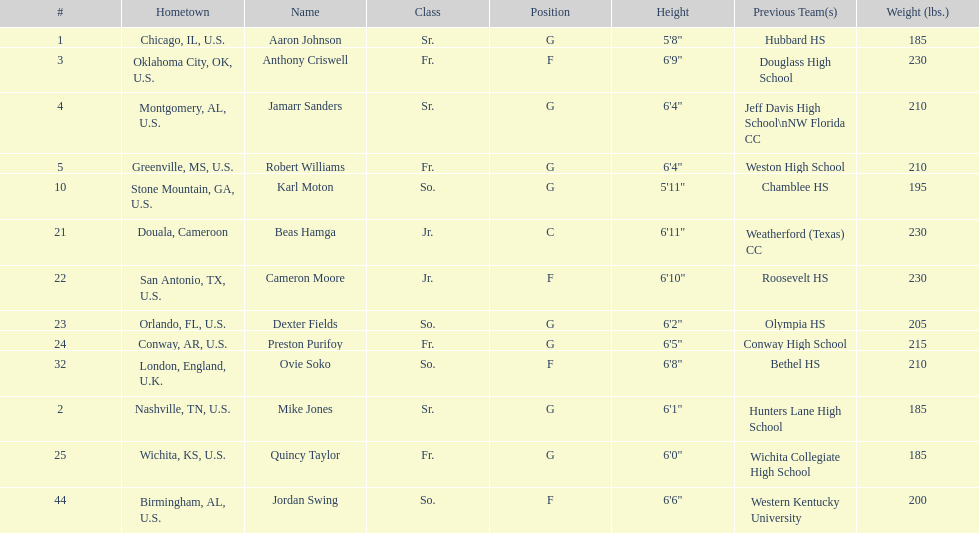Tell me the number of juniors on the team. 2. 